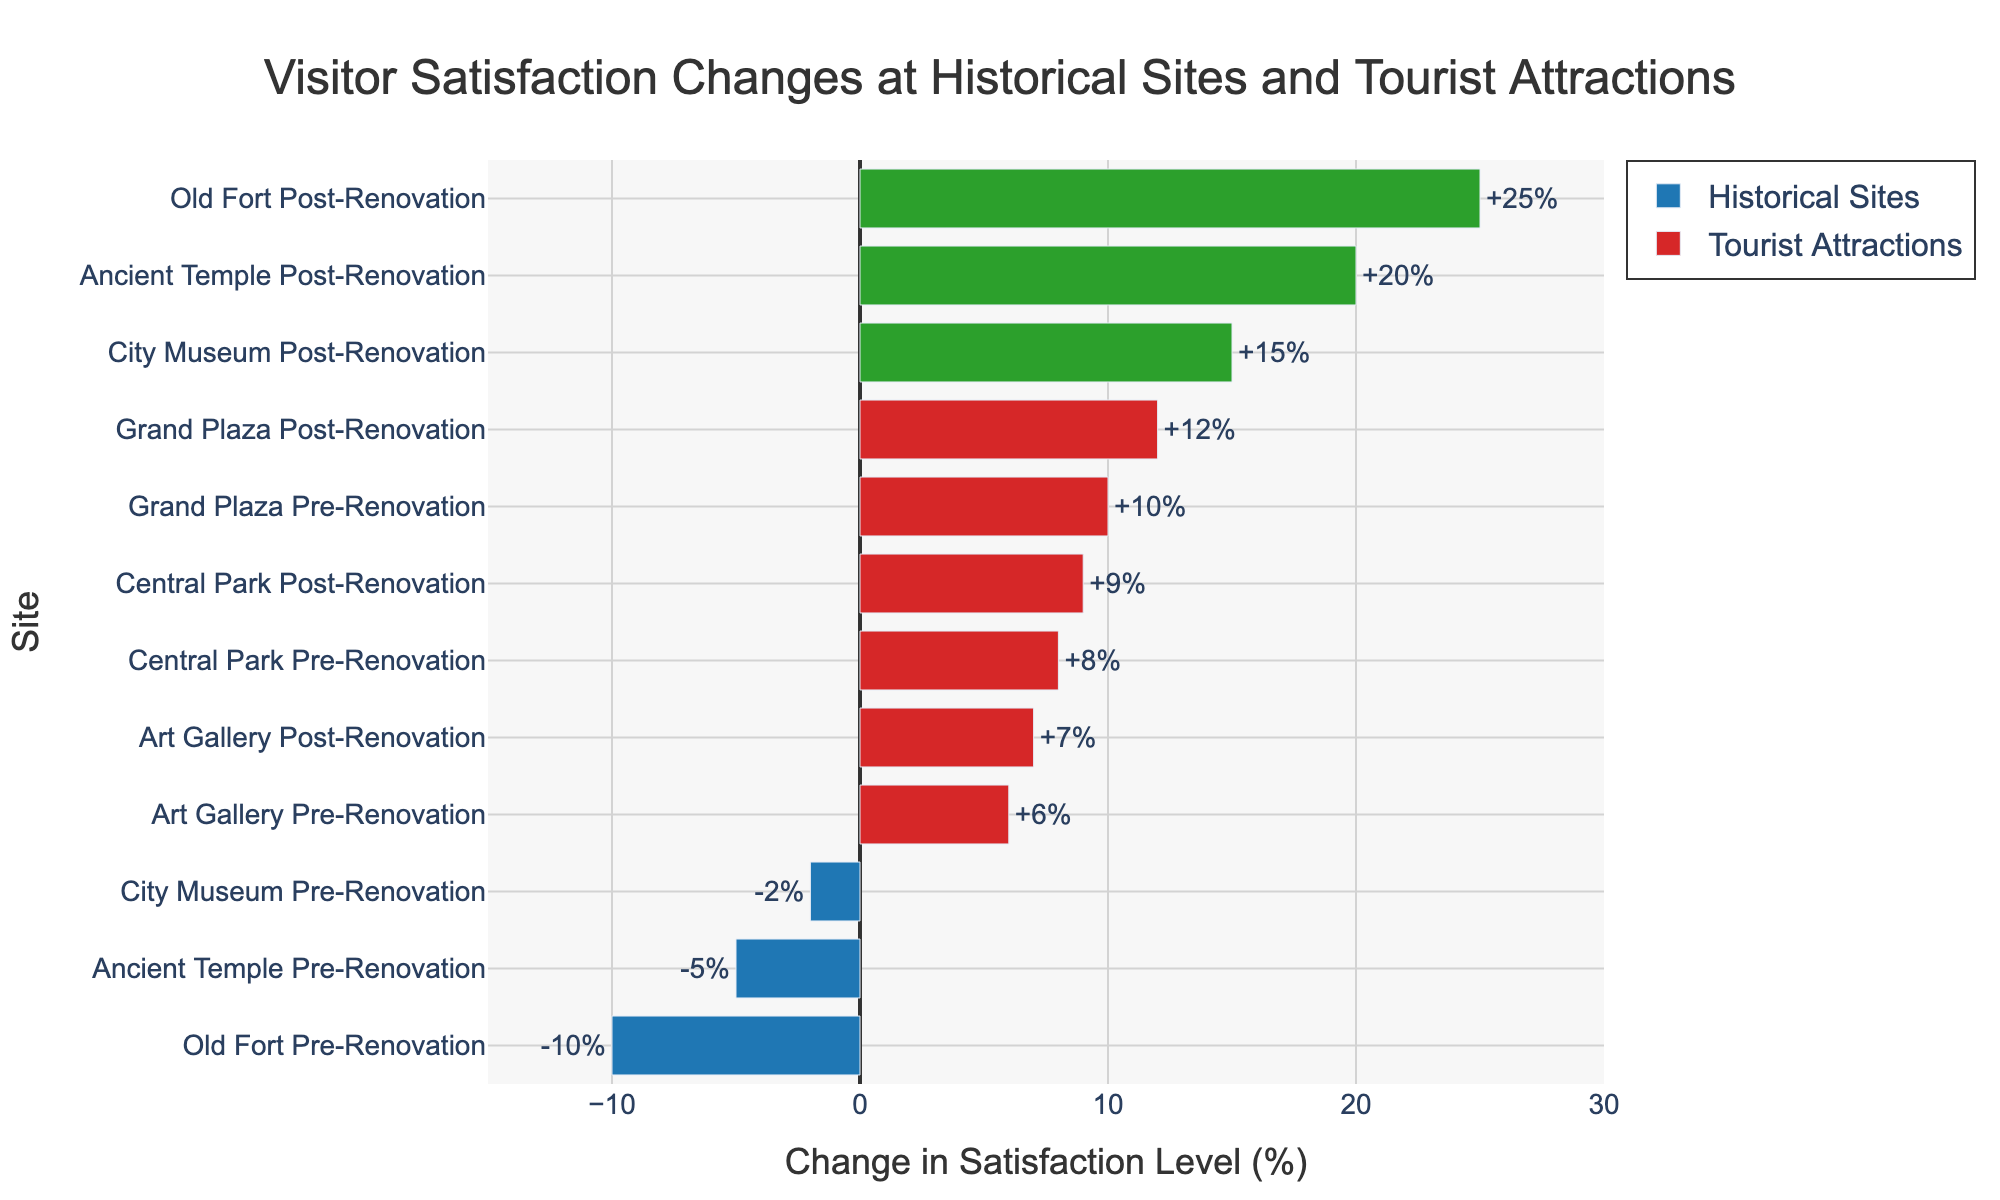Which historical site saw the greatest increase in visitor satisfaction post-renovation? The Old Fort saw the greatest increase from -10% to +25%, which is a change of 35%.
Answer: Old Fort What is the total change in satisfaction for all historical sites post-renovation? The changes are Old Fort (+25%), Ancient Temple (+20%), and City Museum (+15%). Adding these up: 25 + 20 + 15 = 60%
Answer: 60% What is the average change in satisfaction for tourist attractions pre-renovation? The changes are Grand Plaza (+10%), Central Park (+8%), and Art Gallery (+6%). The average is (10 + 8 + 6) / 3 = 8%.
Answer: 8% Which tourist attraction had the smallest change in visitor satisfaction post-renovation? The smallest change post-renovation for tourist attractions is 7% at the Art Gallery.
Answer: Art Gallery How does the visitor satisfaction change at the City Museum post-renovation compare to that at the Grand Plaza post-renovation? City Museum sees a 15% increase while the Grand Plaza sees a 12% increase. Therefore, City Museum's change is greater.
Answer: City Museum's change is greater What is the combined change in satisfaction for the Old Fort and Ancient Temple pre-renovation? Old Fort has -10% and Ancient Temple has -5%. Combined, it is -10 + (-5) = -15%.
Answer: -15% Which site experienced the largest decrease in visitor satisfaction pre-renovation? Old Fort experienced the largest decrease, with satisfaction dropping by 10%.
Answer: Old Fort What are the color codes for satisfaction improvement and decline in historical sites? The colors for improvement are green for positive changes and blue for negative changes in historical sites.
Answer: Green and blue How much more did satisfaction improve for the Ancient Temple post-renovation compared to pre-renovation? Satisfaction improved from -5% (pre-renovation) to +20% (post-renovation), an increase of 25%.
Answer: 25% By how much did the satisfaction change at the Grand Plaza differ between pre- and post-renovation? Grand Plaza saw a pre-renovation change of +10% and a post-renovation change of +12%. The difference is 12 - 10 = 2%.
Answer: 2% 